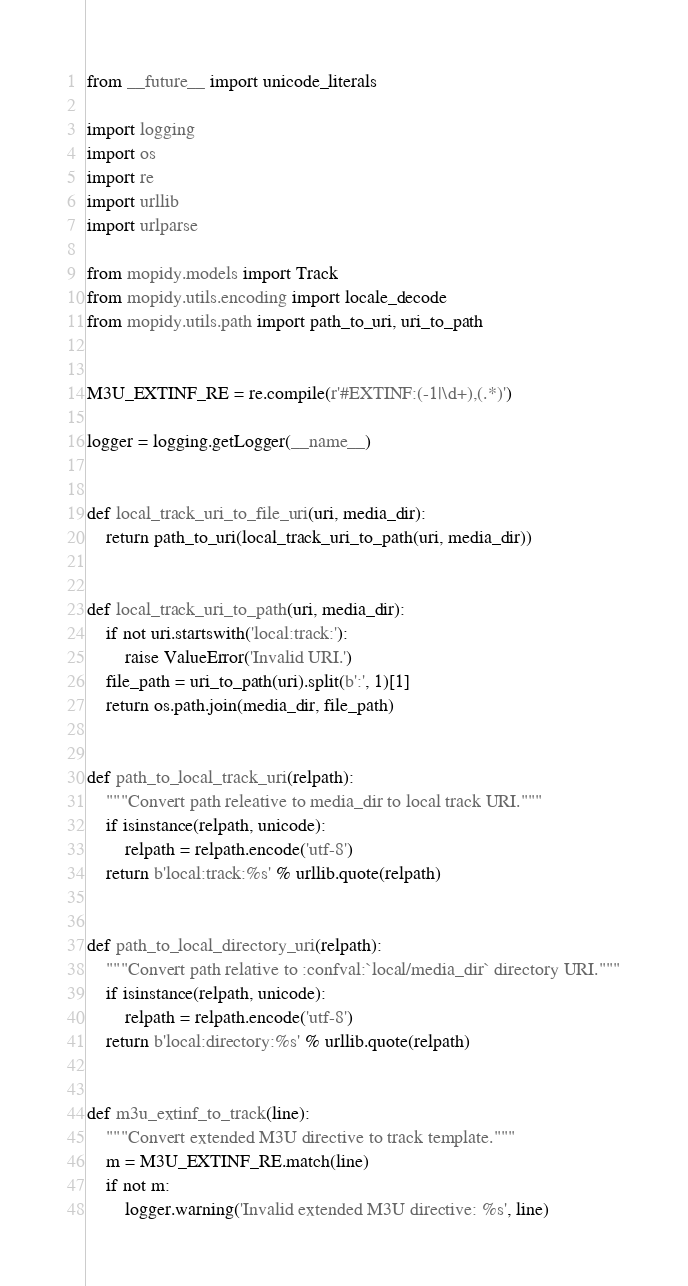Convert code to text. <code><loc_0><loc_0><loc_500><loc_500><_Python_>from __future__ import unicode_literals

import logging
import os
import re
import urllib
import urlparse

from mopidy.models import Track
from mopidy.utils.encoding import locale_decode
from mopidy.utils.path import path_to_uri, uri_to_path


M3U_EXTINF_RE = re.compile(r'#EXTINF:(-1|\d+),(.*)')

logger = logging.getLogger(__name__)


def local_track_uri_to_file_uri(uri, media_dir):
    return path_to_uri(local_track_uri_to_path(uri, media_dir))


def local_track_uri_to_path(uri, media_dir):
    if not uri.startswith('local:track:'):
        raise ValueError('Invalid URI.')
    file_path = uri_to_path(uri).split(b':', 1)[1]
    return os.path.join(media_dir, file_path)


def path_to_local_track_uri(relpath):
    """Convert path releative to media_dir to local track URI."""
    if isinstance(relpath, unicode):
        relpath = relpath.encode('utf-8')
    return b'local:track:%s' % urllib.quote(relpath)


def path_to_local_directory_uri(relpath):
    """Convert path relative to :confval:`local/media_dir` directory URI."""
    if isinstance(relpath, unicode):
        relpath = relpath.encode('utf-8')
    return b'local:directory:%s' % urllib.quote(relpath)


def m3u_extinf_to_track(line):
    """Convert extended M3U directive to track template."""
    m = M3U_EXTINF_RE.match(line)
    if not m:
        logger.warning('Invalid extended M3U directive: %s', line)</code> 